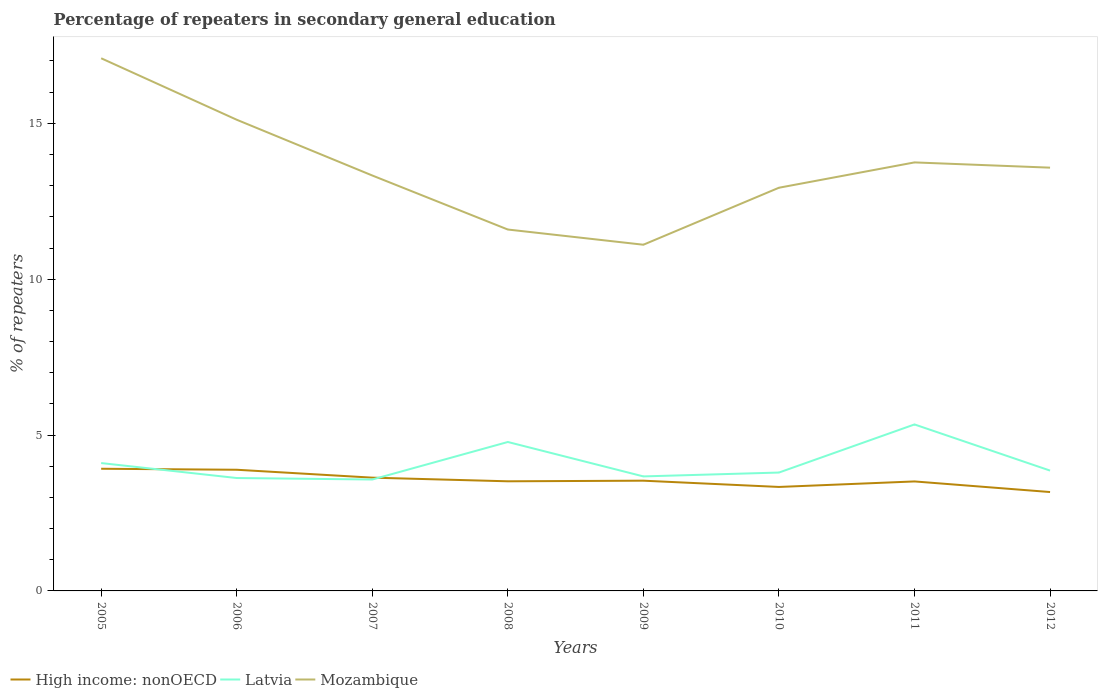Across all years, what is the maximum percentage of repeaters in secondary general education in High income: nonOECD?
Keep it short and to the point. 3.17. What is the total percentage of repeaters in secondary general education in High income: nonOECD in the graph?
Make the answer very short. 0.37. What is the difference between the highest and the second highest percentage of repeaters in secondary general education in Latvia?
Offer a terse response. 1.77. What is the difference between the highest and the lowest percentage of repeaters in secondary general education in Latvia?
Your answer should be very brief. 3. How many lines are there?
Your response must be concise. 3. How many years are there in the graph?
Provide a short and direct response. 8. What is the difference between two consecutive major ticks on the Y-axis?
Offer a very short reply. 5. Does the graph contain any zero values?
Give a very brief answer. No. How are the legend labels stacked?
Keep it short and to the point. Horizontal. What is the title of the graph?
Your answer should be very brief. Percentage of repeaters in secondary general education. Does "European Union" appear as one of the legend labels in the graph?
Ensure brevity in your answer.  No. What is the label or title of the X-axis?
Your answer should be compact. Years. What is the label or title of the Y-axis?
Make the answer very short. % of repeaters. What is the % of repeaters of High income: nonOECD in 2005?
Keep it short and to the point. 3.92. What is the % of repeaters in Latvia in 2005?
Ensure brevity in your answer.  4.1. What is the % of repeaters in Mozambique in 2005?
Give a very brief answer. 17.09. What is the % of repeaters of High income: nonOECD in 2006?
Offer a very short reply. 3.89. What is the % of repeaters in Latvia in 2006?
Provide a short and direct response. 3.62. What is the % of repeaters of Mozambique in 2006?
Your answer should be compact. 15.12. What is the % of repeaters of High income: nonOECD in 2007?
Keep it short and to the point. 3.63. What is the % of repeaters in Latvia in 2007?
Provide a short and direct response. 3.57. What is the % of repeaters in Mozambique in 2007?
Ensure brevity in your answer.  13.33. What is the % of repeaters in High income: nonOECD in 2008?
Keep it short and to the point. 3.52. What is the % of repeaters in Latvia in 2008?
Offer a terse response. 4.78. What is the % of repeaters of Mozambique in 2008?
Your answer should be very brief. 11.59. What is the % of repeaters of High income: nonOECD in 2009?
Your answer should be compact. 3.54. What is the % of repeaters in Latvia in 2009?
Provide a succinct answer. 3.67. What is the % of repeaters of Mozambique in 2009?
Provide a short and direct response. 11.11. What is the % of repeaters in High income: nonOECD in 2010?
Ensure brevity in your answer.  3.34. What is the % of repeaters of Latvia in 2010?
Offer a terse response. 3.8. What is the % of repeaters in Mozambique in 2010?
Keep it short and to the point. 12.93. What is the % of repeaters in High income: nonOECD in 2011?
Keep it short and to the point. 3.51. What is the % of repeaters of Latvia in 2011?
Your answer should be very brief. 5.34. What is the % of repeaters of Mozambique in 2011?
Offer a very short reply. 13.75. What is the % of repeaters in High income: nonOECD in 2012?
Offer a very short reply. 3.17. What is the % of repeaters of Latvia in 2012?
Offer a terse response. 3.86. What is the % of repeaters of Mozambique in 2012?
Provide a succinct answer. 13.58. Across all years, what is the maximum % of repeaters of High income: nonOECD?
Make the answer very short. 3.92. Across all years, what is the maximum % of repeaters in Latvia?
Keep it short and to the point. 5.34. Across all years, what is the maximum % of repeaters in Mozambique?
Provide a succinct answer. 17.09. Across all years, what is the minimum % of repeaters in High income: nonOECD?
Ensure brevity in your answer.  3.17. Across all years, what is the minimum % of repeaters in Latvia?
Offer a terse response. 3.57. Across all years, what is the minimum % of repeaters of Mozambique?
Offer a very short reply. 11.11. What is the total % of repeaters of High income: nonOECD in the graph?
Offer a terse response. 28.51. What is the total % of repeaters of Latvia in the graph?
Provide a short and direct response. 32.75. What is the total % of repeaters in Mozambique in the graph?
Your answer should be very brief. 108.49. What is the difference between the % of repeaters of High income: nonOECD in 2005 and that in 2006?
Your response must be concise. 0.03. What is the difference between the % of repeaters in Latvia in 2005 and that in 2006?
Your answer should be very brief. 0.48. What is the difference between the % of repeaters in Mozambique in 2005 and that in 2006?
Make the answer very short. 1.97. What is the difference between the % of repeaters of High income: nonOECD in 2005 and that in 2007?
Your answer should be very brief. 0.29. What is the difference between the % of repeaters of Latvia in 2005 and that in 2007?
Provide a short and direct response. 0.53. What is the difference between the % of repeaters in Mozambique in 2005 and that in 2007?
Your answer should be very brief. 3.76. What is the difference between the % of repeaters of High income: nonOECD in 2005 and that in 2008?
Offer a terse response. 0.4. What is the difference between the % of repeaters in Latvia in 2005 and that in 2008?
Provide a short and direct response. -0.68. What is the difference between the % of repeaters of Mozambique in 2005 and that in 2008?
Ensure brevity in your answer.  5.49. What is the difference between the % of repeaters in High income: nonOECD in 2005 and that in 2009?
Make the answer very short. 0.38. What is the difference between the % of repeaters of Latvia in 2005 and that in 2009?
Provide a succinct answer. 0.43. What is the difference between the % of repeaters of Mozambique in 2005 and that in 2009?
Offer a very short reply. 5.98. What is the difference between the % of repeaters in High income: nonOECD in 2005 and that in 2010?
Provide a short and direct response. 0.58. What is the difference between the % of repeaters of Latvia in 2005 and that in 2010?
Give a very brief answer. 0.3. What is the difference between the % of repeaters in Mozambique in 2005 and that in 2010?
Your response must be concise. 4.15. What is the difference between the % of repeaters of High income: nonOECD in 2005 and that in 2011?
Provide a succinct answer. 0.41. What is the difference between the % of repeaters of Latvia in 2005 and that in 2011?
Offer a very short reply. -1.24. What is the difference between the % of repeaters in Mozambique in 2005 and that in 2011?
Offer a terse response. 3.34. What is the difference between the % of repeaters of High income: nonOECD in 2005 and that in 2012?
Make the answer very short. 0.75. What is the difference between the % of repeaters of Latvia in 2005 and that in 2012?
Keep it short and to the point. 0.24. What is the difference between the % of repeaters of Mozambique in 2005 and that in 2012?
Make the answer very short. 3.51. What is the difference between the % of repeaters of High income: nonOECD in 2006 and that in 2007?
Offer a terse response. 0.25. What is the difference between the % of repeaters in Latvia in 2006 and that in 2007?
Give a very brief answer. 0.05. What is the difference between the % of repeaters of Mozambique in 2006 and that in 2007?
Your response must be concise. 1.79. What is the difference between the % of repeaters in High income: nonOECD in 2006 and that in 2008?
Make the answer very short. 0.37. What is the difference between the % of repeaters of Latvia in 2006 and that in 2008?
Make the answer very short. -1.16. What is the difference between the % of repeaters of Mozambique in 2006 and that in 2008?
Your answer should be compact. 3.52. What is the difference between the % of repeaters in High income: nonOECD in 2006 and that in 2009?
Ensure brevity in your answer.  0.35. What is the difference between the % of repeaters in Latvia in 2006 and that in 2009?
Give a very brief answer. -0.05. What is the difference between the % of repeaters of Mozambique in 2006 and that in 2009?
Your response must be concise. 4.01. What is the difference between the % of repeaters of High income: nonOECD in 2006 and that in 2010?
Your answer should be compact. 0.55. What is the difference between the % of repeaters in Latvia in 2006 and that in 2010?
Your response must be concise. -0.18. What is the difference between the % of repeaters of Mozambique in 2006 and that in 2010?
Offer a terse response. 2.18. What is the difference between the % of repeaters in High income: nonOECD in 2006 and that in 2011?
Give a very brief answer. 0.37. What is the difference between the % of repeaters in Latvia in 2006 and that in 2011?
Provide a short and direct response. -1.72. What is the difference between the % of repeaters of Mozambique in 2006 and that in 2011?
Provide a short and direct response. 1.37. What is the difference between the % of repeaters of High income: nonOECD in 2006 and that in 2012?
Your answer should be compact. 0.72. What is the difference between the % of repeaters in Latvia in 2006 and that in 2012?
Offer a very short reply. -0.24. What is the difference between the % of repeaters of Mozambique in 2006 and that in 2012?
Give a very brief answer. 1.54. What is the difference between the % of repeaters in High income: nonOECD in 2007 and that in 2008?
Make the answer very short. 0.12. What is the difference between the % of repeaters of Latvia in 2007 and that in 2008?
Provide a succinct answer. -1.2. What is the difference between the % of repeaters of Mozambique in 2007 and that in 2008?
Make the answer very short. 1.73. What is the difference between the % of repeaters of High income: nonOECD in 2007 and that in 2009?
Keep it short and to the point. 0.1. What is the difference between the % of repeaters of Latvia in 2007 and that in 2009?
Give a very brief answer. -0.1. What is the difference between the % of repeaters of Mozambique in 2007 and that in 2009?
Your answer should be very brief. 2.22. What is the difference between the % of repeaters in High income: nonOECD in 2007 and that in 2010?
Make the answer very short. 0.3. What is the difference between the % of repeaters of Latvia in 2007 and that in 2010?
Provide a short and direct response. -0.22. What is the difference between the % of repeaters in Mozambique in 2007 and that in 2010?
Ensure brevity in your answer.  0.39. What is the difference between the % of repeaters of High income: nonOECD in 2007 and that in 2011?
Provide a short and direct response. 0.12. What is the difference between the % of repeaters of Latvia in 2007 and that in 2011?
Offer a terse response. -1.77. What is the difference between the % of repeaters in Mozambique in 2007 and that in 2011?
Ensure brevity in your answer.  -0.42. What is the difference between the % of repeaters of High income: nonOECD in 2007 and that in 2012?
Make the answer very short. 0.46. What is the difference between the % of repeaters of Latvia in 2007 and that in 2012?
Provide a succinct answer. -0.29. What is the difference between the % of repeaters of Mozambique in 2007 and that in 2012?
Your answer should be compact. -0.25. What is the difference between the % of repeaters in High income: nonOECD in 2008 and that in 2009?
Make the answer very short. -0.02. What is the difference between the % of repeaters of Latvia in 2008 and that in 2009?
Your answer should be very brief. 1.1. What is the difference between the % of repeaters of Mozambique in 2008 and that in 2009?
Provide a short and direct response. 0.49. What is the difference between the % of repeaters in High income: nonOECD in 2008 and that in 2010?
Offer a terse response. 0.18. What is the difference between the % of repeaters of Latvia in 2008 and that in 2010?
Your answer should be compact. 0.98. What is the difference between the % of repeaters of Mozambique in 2008 and that in 2010?
Give a very brief answer. -1.34. What is the difference between the % of repeaters in High income: nonOECD in 2008 and that in 2011?
Make the answer very short. 0. What is the difference between the % of repeaters of Latvia in 2008 and that in 2011?
Give a very brief answer. -0.56. What is the difference between the % of repeaters in Mozambique in 2008 and that in 2011?
Offer a very short reply. -2.15. What is the difference between the % of repeaters in High income: nonOECD in 2008 and that in 2012?
Give a very brief answer. 0.34. What is the difference between the % of repeaters in Latvia in 2008 and that in 2012?
Provide a short and direct response. 0.92. What is the difference between the % of repeaters in Mozambique in 2008 and that in 2012?
Give a very brief answer. -1.98. What is the difference between the % of repeaters of High income: nonOECD in 2009 and that in 2010?
Give a very brief answer. 0.2. What is the difference between the % of repeaters of Latvia in 2009 and that in 2010?
Make the answer very short. -0.12. What is the difference between the % of repeaters of Mozambique in 2009 and that in 2010?
Provide a short and direct response. -1.83. What is the difference between the % of repeaters in High income: nonOECD in 2009 and that in 2011?
Give a very brief answer. 0.02. What is the difference between the % of repeaters in Latvia in 2009 and that in 2011?
Provide a short and direct response. -1.67. What is the difference between the % of repeaters in Mozambique in 2009 and that in 2011?
Your response must be concise. -2.64. What is the difference between the % of repeaters of High income: nonOECD in 2009 and that in 2012?
Offer a very short reply. 0.36. What is the difference between the % of repeaters in Latvia in 2009 and that in 2012?
Give a very brief answer. -0.19. What is the difference between the % of repeaters of Mozambique in 2009 and that in 2012?
Make the answer very short. -2.47. What is the difference between the % of repeaters of High income: nonOECD in 2010 and that in 2011?
Offer a very short reply. -0.18. What is the difference between the % of repeaters in Latvia in 2010 and that in 2011?
Give a very brief answer. -1.54. What is the difference between the % of repeaters in Mozambique in 2010 and that in 2011?
Provide a short and direct response. -0.81. What is the difference between the % of repeaters of High income: nonOECD in 2010 and that in 2012?
Provide a short and direct response. 0.16. What is the difference between the % of repeaters in Latvia in 2010 and that in 2012?
Ensure brevity in your answer.  -0.06. What is the difference between the % of repeaters of Mozambique in 2010 and that in 2012?
Your answer should be compact. -0.64. What is the difference between the % of repeaters of High income: nonOECD in 2011 and that in 2012?
Your response must be concise. 0.34. What is the difference between the % of repeaters of Latvia in 2011 and that in 2012?
Give a very brief answer. 1.48. What is the difference between the % of repeaters in Mozambique in 2011 and that in 2012?
Make the answer very short. 0.17. What is the difference between the % of repeaters in High income: nonOECD in 2005 and the % of repeaters in Latvia in 2006?
Your answer should be very brief. 0.3. What is the difference between the % of repeaters in High income: nonOECD in 2005 and the % of repeaters in Mozambique in 2006?
Give a very brief answer. -11.2. What is the difference between the % of repeaters in Latvia in 2005 and the % of repeaters in Mozambique in 2006?
Provide a short and direct response. -11.01. What is the difference between the % of repeaters in High income: nonOECD in 2005 and the % of repeaters in Latvia in 2007?
Offer a terse response. 0.35. What is the difference between the % of repeaters of High income: nonOECD in 2005 and the % of repeaters of Mozambique in 2007?
Your answer should be compact. -9.41. What is the difference between the % of repeaters of Latvia in 2005 and the % of repeaters of Mozambique in 2007?
Offer a very short reply. -9.23. What is the difference between the % of repeaters of High income: nonOECD in 2005 and the % of repeaters of Latvia in 2008?
Give a very brief answer. -0.86. What is the difference between the % of repeaters in High income: nonOECD in 2005 and the % of repeaters in Mozambique in 2008?
Give a very brief answer. -7.67. What is the difference between the % of repeaters in Latvia in 2005 and the % of repeaters in Mozambique in 2008?
Provide a short and direct response. -7.49. What is the difference between the % of repeaters of High income: nonOECD in 2005 and the % of repeaters of Latvia in 2009?
Offer a very short reply. 0.25. What is the difference between the % of repeaters of High income: nonOECD in 2005 and the % of repeaters of Mozambique in 2009?
Provide a short and direct response. -7.19. What is the difference between the % of repeaters of Latvia in 2005 and the % of repeaters of Mozambique in 2009?
Your answer should be very brief. -7. What is the difference between the % of repeaters of High income: nonOECD in 2005 and the % of repeaters of Latvia in 2010?
Provide a succinct answer. 0.12. What is the difference between the % of repeaters of High income: nonOECD in 2005 and the % of repeaters of Mozambique in 2010?
Ensure brevity in your answer.  -9.02. What is the difference between the % of repeaters of Latvia in 2005 and the % of repeaters of Mozambique in 2010?
Give a very brief answer. -8.83. What is the difference between the % of repeaters in High income: nonOECD in 2005 and the % of repeaters in Latvia in 2011?
Your response must be concise. -1.42. What is the difference between the % of repeaters in High income: nonOECD in 2005 and the % of repeaters in Mozambique in 2011?
Ensure brevity in your answer.  -9.83. What is the difference between the % of repeaters in Latvia in 2005 and the % of repeaters in Mozambique in 2011?
Offer a very short reply. -9.64. What is the difference between the % of repeaters in High income: nonOECD in 2005 and the % of repeaters in Latvia in 2012?
Make the answer very short. 0.06. What is the difference between the % of repeaters in High income: nonOECD in 2005 and the % of repeaters in Mozambique in 2012?
Provide a short and direct response. -9.66. What is the difference between the % of repeaters in Latvia in 2005 and the % of repeaters in Mozambique in 2012?
Your answer should be compact. -9.48. What is the difference between the % of repeaters of High income: nonOECD in 2006 and the % of repeaters of Latvia in 2007?
Make the answer very short. 0.31. What is the difference between the % of repeaters in High income: nonOECD in 2006 and the % of repeaters in Mozambique in 2007?
Keep it short and to the point. -9.44. What is the difference between the % of repeaters of Latvia in 2006 and the % of repeaters of Mozambique in 2007?
Keep it short and to the point. -9.71. What is the difference between the % of repeaters in High income: nonOECD in 2006 and the % of repeaters in Latvia in 2008?
Ensure brevity in your answer.  -0.89. What is the difference between the % of repeaters of High income: nonOECD in 2006 and the % of repeaters of Mozambique in 2008?
Your answer should be very brief. -7.71. What is the difference between the % of repeaters of Latvia in 2006 and the % of repeaters of Mozambique in 2008?
Your answer should be very brief. -7.97. What is the difference between the % of repeaters of High income: nonOECD in 2006 and the % of repeaters of Latvia in 2009?
Provide a succinct answer. 0.21. What is the difference between the % of repeaters in High income: nonOECD in 2006 and the % of repeaters in Mozambique in 2009?
Offer a terse response. -7.22. What is the difference between the % of repeaters in Latvia in 2006 and the % of repeaters in Mozambique in 2009?
Provide a short and direct response. -7.48. What is the difference between the % of repeaters in High income: nonOECD in 2006 and the % of repeaters in Latvia in 2010?
Provide a succinct answer. 0.09. What is the difference between the % of repeaters in High income: nonOECD in 2006 and the % of repeaters in Mozambique in 2010?
Offer a very short reply. -9.05. What is the difference between the % of repeaters of Latvia in 2006 and the % of repeaters of Mozambique in 2010?
Your answer should be compact. -9.31. What is the difference between the % of repeaters of High income: nonOECD in 2006 and the % of repeaters of Latvia in 2011?
Give a very brief answer. -1.45. What is the difference between the % of repeaters of High income: nonOECD in 2006 and the % of repeaters of Mozambique in 2011?
Provide a short and direct response. -9.86. What is the difference between the % of repeaters in Latvia in 2006 and the % of repeaters in Mozambique in 2011?
Your answer should be compact. -10.12. What is the difference between the % of repeaters in High income: nonOECD in 2006 and the % of repeaters in Latvia in 2012?
Provide a succinct answer. 0.03. What is the difference between the % of repeaters in High income: nonOECD in 2006 and the % of repeaters in Mozambique in 2012?
Make the answer very short. -9.69. What is the difference between the % of repeaters of Latvia in 2006 and the % of repeaters of Mozambique in 2012?
Keep it short and to the point. -9.96. What is the difference between the % of repeaters in High income: nonOECD in 2007 and the % of repeaters in Latvia in 2008?
Your response must be concise. -1.14. What is the difference between the % of repeaters of High income: nonOECD in 2007 and the % of repeaters of Mozambique in 2008?
Offer a terse response. -7.96. What is the difference between the % of repeaters in Latvia in 2007 and the % of repeaters in Mozambique in 2008?
Provide a short and direct response. -8.02. What is the difference between the % of repeaters in High income: nonOECD in 2007 and the % of repeaters in Latvia in 2009?
Make the answer very short. -0.04. What is the difference between the % of repeaters in High income: nonOECD in 2007 and the % of repeaters in Mozambique in 2009?
Give a very brief answer. -7.47. What is the difference between the % of repeaters in Latvia in 2007 and the % of repeaters in Mozambique in 2009?
Offer a very short reply. -7.53. What is the difference between the % of repeaters of High income: nonOECD in 2007 and the % of repeaters of Latvia in 2010?
Give a very brief answer. -0.16. What is the difference between the % of repeaters in High income: nonOECD in 2007 and the % of repeaters in Mozambique in 2010?
Provide a succinct answer. -9.3. What is the difference between the % of repeaters in Latvia in 2007 and the % of repeaters in Mozambique in 2010?
Offer a very short reply. -9.36. What is the difference between the % of repeaters in High income: nonOECD in 2007 and the % of repeaters in Latvia in 2011?
Your answer should be compact. -1.71. What is the difference between the % of repeaters in High income: nonOECD in 2007 and the % of repeaters in Mozambique in 2011?
Your answer should be very brief. -10.11. What is the difference between the % of repeaters of Latvia in 2007 and the % of repeaters of Mozambique in 2011?
Offer a very short reply. -10.17. What is the difference between the % of repeaters in High income: nonOECD in 2007 and the % of repeaters in Latvia in 2012?
Keep it short and to the point. -0.23. What is the difference between the % of repeaters of High income: nonOECD in 2007 and the % of repeaters of Mozambique in 2012?
Offer a very short reply. -9.95. What is the difference between the % of repeaters of Latvia in 2007 and the % of repeaters of Mozambique in 2012?
Your response must be concise. -10. What is the difference between the % of repeaters of High income: nonOECD in 2008 and the % of repeaters of Latvia in 2009?
Keep it short and to the point. -0.16. What is the difference between the % of repeaters in High income: nonOECD in 2008 and the % of repeaters in Mozambique in 2009?
Make the answer very short. -7.59. What is the difference between the % of repeaters of Latvia in 2008 and the % of repeaters of Mozambique in 2009?
Make the answer very short. -6.33. What is the difference between the % of repeaters in High income: nonOECD in 2008 and the % of repeaters in Latvia in 2010?
Your answer should be very brief. -0.28. What is the difference between the % of repeaters of High income: nonOECD in 2008 and the % of repeaters of Mozambique in 2010?
Offer a very short reply. -9.42. What is the difference between the % of repeaters of Latvia in 2008 and the % of repeaters of Mozambique in 2010?
Give a very brief answer. -8.16. What is the difference between the % of repeaters in High income: nonOECD in 2008 and the % of repeaters in Latvia in 2011?
Offer a very short reply. -1.82. What is the difference between the % of repeaters of High income: nonOECD in 2008 and the % of repeaters of Mozambique in 2011?
Make the answer very short. -10.23. What is the difference between the % of repeaters in Latvia in 2008 and the % of repeaters in Mozambique in 2011?
Your answer should be very brief. -8.97. What is the difference between the % of repeaters in High income: nonOECD in 2008 and the % of repeaters in Latvia in 2012?
Your answer should be compact. -0.34. What is the difference between the % of repeaters in High income: nonOECD in 2008 and the % of repeaters in Mozambique in 2012?
Your response must be concise. -10.06. What is the difference between the % of repeaters of Latvia in 2008 and the % of repeaters of Mozambique in 2012?
Provide a succinct answer. -8.8. What is the difference between the % of repeaters in High income: nonOECD in 2009 and the % of repeaters in Latvia in 2010?
Provide a succinct answer. -0.26. What is the difference between the % of repeaters in High income: nonOECD in 2009 and the % of repeaters in Mozambique in 2010?
Make the answer very short. -9.4. What is the difference between the % of repeaters of Latvia in 2009 and the % of repeaters of Mozambique in 2010?
Ensure brevity in your answer.  -9.26. What is the difference between the % of repeaters in High income: nonOECD in 2009 and the % of repeaters in Latvia in 2011?
Ensure brevity in your answer.  -1.8. What is the difference between the % of repeaters of High income: nonOECD in 2009 and the % of repeaters of Mozambique in 2011?
Your answer should be compact. -10.21. What is the difference between the % of repeaters in Latvia in 2009 and the % of repeaters in Mozambique in 2011?
Make the answer very short. -10.07. What is the difference between the % of repeaters of High income: nonOECD in 2009 and the % of repeaters of Latvia in 2012?
Keep it short and to the point. -0.32. What is the difference between the % of repeaters in High income: nonOECD in 2009 and the % of repeaters in Mozambique in 2012?
Your response must be concise. -10.04. What is the difference between the % of repeaters in Latvia in 2009 and the % of repeaters in Mozambique in 2012?
Ensure brevity in your answer.  -9.9. What is the difference between the % of repeaters of High income: nonOECD in 2010 and the % of repeaters of Latvia in 2011?
Offer a very short reply. -2. What is the difference between the % of repeaters in High income: nonOECD in 2010 and the % of repeaters in Mozambique in 2011?
Give a very brief answer. -10.41. What is the difference between the % of repeaters in Latvia in 2010 and the % of repeaters in Mozambique in 2011?
Provide a short and direct response. -9.95. What is the difference between the % of repeaters of High income: nonOECD in 2010 and the % of repeaters of Latvia in 2012?
Offer a very short reply. -0.52. What is the difference between the % of repeaters of High income: nonOECD in 2010 and the % of repeaters of Mozambique in 2012?
Keep it short and to the point. -10.24. What is the difference between the % of repeaters of Latvia in 2010 and the % of repeaters of Mozambique in 2012?
Make the answer very short. -9.78. What is the difference between the % of repeaters of High income: nonOECD in 2011 and the % of repeaters of Latvia in 2012?
Offer a very short reply. -0.35. What is the difference between the % of repeaters in High income: nonOECD in 2011 and the % of repeaters in Mozambique in 2012?
Your response must be concise. -10.07. What is the difference between the % of repeaters in Latvia in 2011 and the % of repeaters in Mozambique in 2012?
Your response must be concise. -8.24. What is the average % of repeaters of High income: nonOECD per year?
Provide a short and direct response. 3.56. What is the average % of repeaters in Latvia per year?
Offer a terse response. 4.09. What is the average % of repeaters of Mozambique per year?
Offer a very short reply. 13.56. In the year 2005, what is the difference between the % of repeaters in High income: nonOECD and % of repeaters in Latvia?
Provide a short and direct response. -0.18. In the year 2005, what is the difference between the % of repeaters in High income: nonOECD and % of repeaters in Mozambique?
Provide a short and direct response. -13.17. In the year 2005, what is the difference between the % of repeaters in Latvia and % of repeaters in Mozambique?
Offer a terse response. -12.99. In the year 2006, what is the difference between the % of repeaters in High income: nonOECD and % of repeaters in Latvia?
Provide a succinct answer. 0.27. In the year 2006, what is the difference between the % of repeaters in High income: nonOECD and % of repeaters in Mozambique?
Ensure brevity in your answer.  -11.23. In the year 2006, what is the difference between the % of repeaters in Latvia and % of repeaters in Mozambique?
Your answer should be very brief. -11.49. In the year 2007, what is the difference between the % of repeaters in High income: nonOECD and % of repeaters in Latvia?
Offer a terse response. 0.06. In the year 2007, what is the difference between the % of repeaters of High income: nonOECD and % of repeaters of Mozambique?
Your answer should be compact. -9.69. In the year 2007, what is the difference between the % of repeaters in Latvia and % of repeaters in Mozambique?
Ensure brevity in your answer.  -9.75. In the year 2008, what is the difference between the % of repeaters of High income: nonOECD and % of repeaters of Latvia?
Keep it short and to the point. -1.26. In the year 2008, what is the difference between the % of repeaters in High income: nonOECD and % of repeaters in Mozambique?
Make the answer very short. -8.08. In the year 2008, what is the difference between the % of repeaters of Latvia and % of repeaters of Mozambique?
Provide a succinct answer. -6.82. In the year 2009, what is the difference between the % of repeaters of High income: nonOECD and % of repeaters of Latvia?
Keep it short and to the point. -0.14. In the year 2009, what is the difference between the % of repeaters in High income: nonOECD and % of repeaters in Mozambique?
Your answer should be compact. -7.57. In the year 2009, what is the difference between the % of repeaters of Latvia and % of repeaters of Mozambique?
Provide a short and direct response. -7.43. In the year 2010, what is the difference between the % of repeaters in High income: nonOECD and % of repeaters in Latvia?
Your answer should be compact. -0.46. In the year 2010, what is the difference between the % of repeaters in High income: nonOECD and % of repeaters in Mozambique?
Provide a succinct answer. -9.6. In the year 2010, what is the difference between the % of repeaters in Latvia and % of repeaters in Mozambique?
Offer a very short reply. -9.14. In the year 2011, what is the difference between the % of repeaters of High income: nonOECD and % of repeaters of Latvia?
Give a very brief answer. -1.83. In the year 2011, what is the difference between the % of repeaters in High income: nonOECD and % of repeaters in Mozambique?
Offer a terse response. -10.23. In the year 2011, what is the difference between the % of repeaters in Latvia and % of repeaters in Mozambique?
Offer a very short reply. -8.41. In the year 2012, what is the difference between the % of repeaters of High income: nonOECD and % of repeaters of Latvia?
Ensure brevity in your answer.  -0.69. In the year 2012, what is the difference between the % of repeaters in High income: nonOECD and % of repeaters in Mozambique?
Your response must be concise. -10.41. In the year 2012, what is the difference between the % of repeaters in Latvia and % of repeaters in Mozambique?
Provide a short and direct response. -9.72. What is the ratio of the % of repeaters in High income: nonOECD in 2005 to that in 2006?
Offer a terse response. 1.01. What is the ratio of the % of repeaters in Latvia in 2005 to that in 2006?
Give a very brief answer. 1.13. What is the ratio of the % of repeaters of Mozambique in 2005 to that in 2006?
Make the answer very short. 1.13. What is the ratio of the % of repeaters in High income: nonOECD in 2005 to that in 2007?
Make the answer very short. 1.08. What is the ratio of the % of repeaters in Latvia in 2005 to that in 2007?
Ensure brevity in your answer.  1.15. What is the ratio of the % of repeaters in Mozambique in 2005 to that in 2007?
Provide a short and direct response. 1.28. What is the ratio of the % of repeaters in High income: nonOECD in 2005 to that in 2008?
Keep it short and to the point. 1.11. What is the ratio of the % of repeaters in Latvia in 2005 to that in 2008?
Offer a terse response. 0.86. What is the ratio of the % of repeaters of Mozambique in 2005 to that in 2008?
Give a very brief answer. 1.47. What is the ratio of the % of repeaters of High income: nonOECD in 2005 to that in 2009?
Ensure brevity in your answer.  1.11. What is the ratio of the % of repeaters of Latvia in 2005 to that in 2009?
Your answer should be very brief. 1.12. What is the ratio of the % of repeaters of Mozambique in 2005 to that in 2009?
Offer a very short reply. 1.54. What is the ratio of the % of repeaters of High income: nonOECD in 2005 to that in 2010?
Your answer should be compact. 1.18. What is the ratio of the % of repeaters in Latvia in 2005 to that in 2010?
Ensure brevity in your answer.  1.08. What is the ratio of the % of repeaters of Mozambique in 2005 to that in 2010?
Provide a short and direct response. 1.32. What is the ratio of the % of repeaters in High income: nonOECD in 2005 to that in 2011?
Your answer should be very brief. 1.12. What is the ratio of the % of repeaters in Latvia in 2005 to that in 2011?
Offer a terse response. 0.77. What is the ratio of the % of repeaters of Mozambique in 2005 to that in 2011?
Ensure brevity in your answer.  1.24. What is the ratio of the % of repeaters of High income: nonOECD in 2005 to that in 2012?
Your answer should be very brief. 1.24. What is the ratio of the % of repeaters in Latvia in 2005 to that in 2012?
Ensure brevity in your answer.  1.06. What is the ratio of the % of repeaters in Mozambique in 2005 to that in 2012?
Keep it short and to the point. 1.26. What is the ratio of the % of repeaters of High income: nonOECD in 2006 to that in 2007?
Provide a short and direct response. 1.07. What is the ratio of the % of repeaters of Latvia in 2006 to that in 2007?
Make the answer very short. 1.01. What is the ratio of the % of repeaters in Mozambique in 2006 to that in 2007?
Offer a terse response. 1.13. What is the ratio of the % of repeaters in High income: nonOECD in 2006 to that in 2008?
Provide a succinct answer. 1.11. What is the ratio of the % of repeaters in Latvia in 2006 to that in 2008?
Offer a terse response. 0.76. What is the ratio of the % of repeaters in Mozambique in 2006 to that in 2008?
Make the answer very short. 1.3. What is the ratio of the % of repeaters in High income: nonOECD in 2006 to that in 2009?
Provide a short and direct response. 1.1. What is the ratio of the % of repeaters of Latvia in 2006 to that in 2009?
Your answer should be compact. 0.99. What is the ratio of the % of repeaters of Mozambique in 2006 to that in 2009?
Your answer should be compact. 1.36. What is the ratio of the % of repeaters in High income: nonOECD in 2006 to that in 2010?
Keep it short and to the point. 1.17. What is the ratio of the % of repeaters in Latvia in 2006 to that in 2010?
Make the answer very short. 0.95. What is the ratio of the % of repeaters in Mozambique in 2006 to that in 2010?
Provide a short and direct response. 1.17. What is the ratio of the % of repeaters of High income: nonOECD in 2006 to that in 2011?
Provide a short and direct response. 1.11. What is the ratio of the % of repeaters of Latvia in 2006 to that in 2011?
Your answer should be very brief. 0.68. What is the ratio of the % of repeaters in Mozambique in 2006 to that in 2011?
Your answer should be very brief. 1.1. What is the ratio of the % of repeaters of High income: nonOECD in 2006 to that in 2012?
Your answer should be very brief. 1.23. What is the ratio of the % of repeaters in Latvia in 2006 to that in 2012?
Your response must be concise. 0.94. What is the ratio of the % of repeaters of Mozambique in 2006 to that in 2012?
Make the answer very short. 1.11. What is the ratio of the % of repeaters in Latvia in 2007 to that in 2008?
Ensure brevity in your answer.  0.75. What is the ratio of the % of repeaters in Mozambique in 2007 to that in 2008?
Offer a terse response. 1.15. What is the ratio of the % of repeaters in High income: nonOECD in 2007 to that in 2009?
Your answer should be very brief. 1.03. What is the ratio of the % of repeaters of Latvia in 2007 to that in 2009?
Offer a terse response. 0.97. What is the ratio of the % of repeaters of Mozambique in 2007 to that in 2009?
Keep it short and to the point. 1.2. What is the ratio of the % of repeaters of High income: nonOECD in 2007 to that in 2010?
Your response must be concise. 1.09. What is the ratio of the % of repeaters of Latvia in 2007 to that in 2010?
Make the answer very short. 0.94. What is the ratio of the % of repeaters in Mozambique in 2007 to that in 2010?
Give a very brief answer. 1.03. What is the ratio of the % of repeaters in High income: nonOECD in 2007 to that in 2011?
Give a very brief answer. 1.03. What is the ratio of the % of repeaters in Latvia in 2007 to that in 2011?
Give a very brief answer. 0.67. What is the ratio of the % of repeaters of Mozambique in 2007 to that in 2011?
Give a very brief answer. 0.97. What is the ratio of the % of repeaters of High income: nonOECD in 2007 to that in 2012?
Your answer should be very brief. 1.15. What is the ratio of the % of repeaters of Latvia in 2007 to that in 2012?
Give a very brief answer. 0.93. What is the ratio of the % of repeaters in Mozambique in 2007 to that in 2012?
Provide a succinct answer. 0.98. What is the ratio of the % of repeaters of High income: nonOECD in 2008 to that in 2009?
Provide a succinct answer. 0.99. What is the ratio of the % of repeaters in Latvia in 2008 to that in 2009?
Keep it short and to the point. 1.3. What is the ratio of the % of repeaters of Mozambique in 2008 to that in 2009?
Give a very brief answer. 1.04. What is the ratio of the % of repeaters of High income: nonOECD in 2008 to that in 2010?
Your response must be concise. 1.05. What is the ratio of the % of repeaters in Latvia in 2008 to that in 2010?
Give a very brief answer. 1.26. What is the ratio of the % of repeaters of Mozambique in 2008 to that in 2010?
Give a very brief answer. 0.9. What is the ratio of the % of repeaters in High income: nonOECD in 2008 to that in 2011?
Your answer should be very brief. 1. What is the ratio of the % of repeaters of Latvia in 2008 to that in 2011?
Give a very brief answer. 0.89. What is the ratio of the % of repeaters of Mozambique in 2008 to that in 2011?
Give a very brief answer. 0.84. What is the ratio of the % of repeaters of High income: nonOECD in 2008 to that in 2012?
Your answer should be compact. 1.11. What is the ratio of the % of repeaters in Latvia in 2008 to that in 2012?
Ensure brevity in your answer.  1.24. What is the ratio of the % of repeaters of Mozambique in 2008 to that in 2012?
Your answer should be very brief. 0.85. What is the ratio of the % of repeaters of High income: nonOECD in 2009 to that in 2010?
Provide a short and direct response. 1.06. What is the ratio of the % of repeaters of Latvia in 2009 to that in 2010?
Offer a very short reply. 0.97. What is the ratio of the % of repeaters in Mozambique in 2009 to that in 2010?
Make the answer very short. 0.86. What is the ratio of the % of repeaters in High income: nonOECD in 2009 to that in 2011?
Provide a succinct answer. 1.01. What is the ratio of the % of repeaters of Latvia in 2009 to that in 2011?
Keep it short and to the point. 0.69. What is the ratio of the % of repeaters of Mozambique in 2009 to that in 2011?
Your response must be concise. 0.81. What is the ratio of the % of repeaters of High income: nonOECD in 2009 to that in 2012?
Your response must be concise. 1.11. What is the ratio of the % of repeaters of Latvia in 2009 to that in 2012?
Offer a very short reply. 0.95. What is the ratio of the % of repeaters in Mozambique in 2009 to that in 2012?
Your response must be concise. 0.82. What is the ratio of the % of repeaters of High income: nonOECD in 2010 to that in 2011?
Give a very brief answer. 0.95. What is the ratio of the % of repeaters of Latvia in 2010 to that in 2011?
Provide a short and direct response. 0.71. What is the ratio of the % of repeaters of Mozambique in 2010 to that in 2011?
Provide a short and direct response. 0.94. What is the ratio of the % of repeaters in High income: nonOECD in 2010 to that in 2012?
Provide a succinct answer. 1.05. What is the ratio of the % of repeaters of Latvia in 2010 to that in 2012?
Ensure brevity in your answer.  0.98. What is the ratio of the % of repeaters of Mozambique in 2010 to that in 2012?
Your answer should be compact. 0.95. What is the ratio of the % of repeaters of High income: nonOECD in 2011 to that in 2012?
Give a very brief answer. 1.11. What is the ratio of the % of repeaters of Latvia in 2011 to that in 2012?
Offer a very short reply. 1.38. What is the ratio of the % of repeaters in Mozambique in 2011 to that in 2012?
Your answer should be very brief. 1.01. What is the difference between the highest and the second highest % of repeaters of High income: nonOECD?
Provide a short and direct response. 0.03. What is the difference between the highest and the second highest % of repeaters of Latvia?
Provide a succinct answer. 0.56. What is the difference between the highest and the second highest % of repeaters of Mozambique?
Ensure brevity in your answer.  1.97. What is the difference between the highest and the lowest % of repeaters in High income: nonOECD?
Your answer should be compact. 0.75. What is the difference between the highest and the lowest % of repeaters in Latvia?
Make the answer very short. 1.77. What is the difference between the highest and the lowest % of repeaters in Mozambique?
Offer a very short reply. 5.98. 